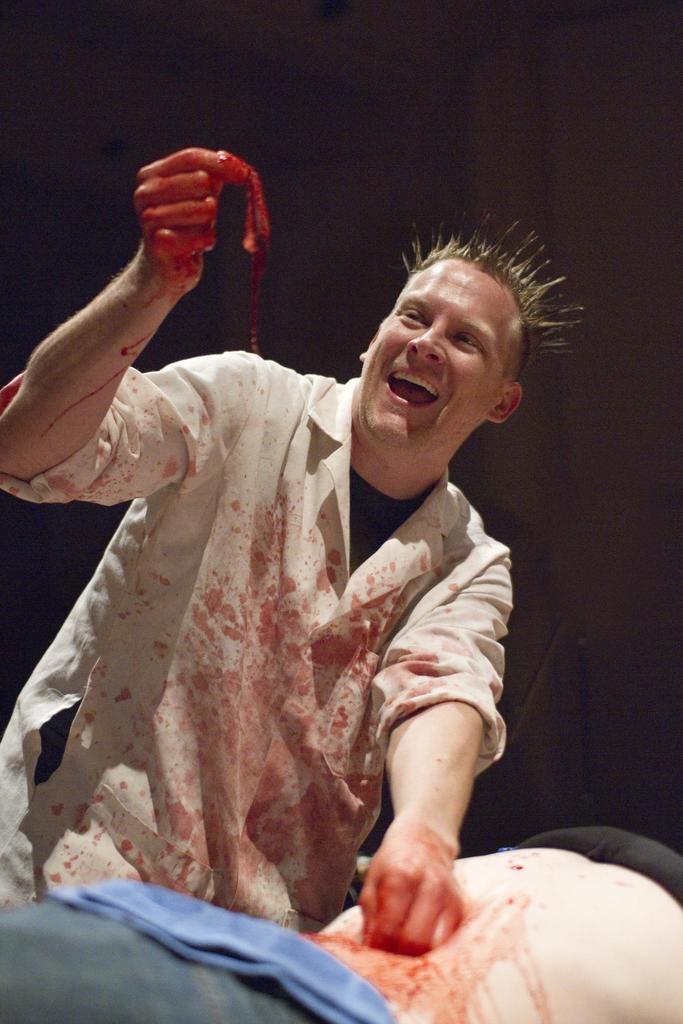Could you give a brief overview of what you see in this image? At the bottom of the image there is a person. Behind the person there is a man standing and holding something in his hand and he is smiling. There is a blood to his hand. And there is a dark background. 